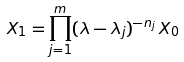Convert formula to latex. <formula><loc_0><loc_0><loc_500><loc_500>X _ { 1 } = \prod _ { j = 1 } ^ { m } ( \lambda - \lambda _ { j } ) ^ { - n _ { j } } \, X _ { 0 }</formula> 